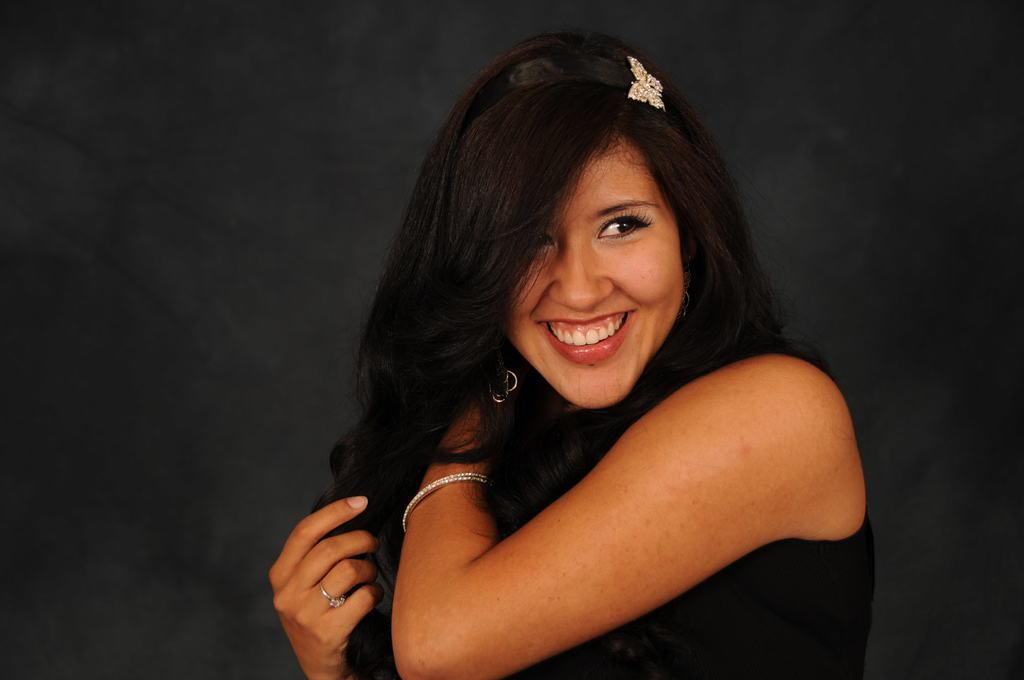What is the main subject of the image? There is a person in the image. What is the person wearing? The person is wearing a black dress. What can be seen in the background of the image? The background of the image is black. What type of chess piece is the person holding in the image? There is no chess piece present in the image. What is the aftermath of the test in the image? There is no test or its aftermath depicted in the image. 